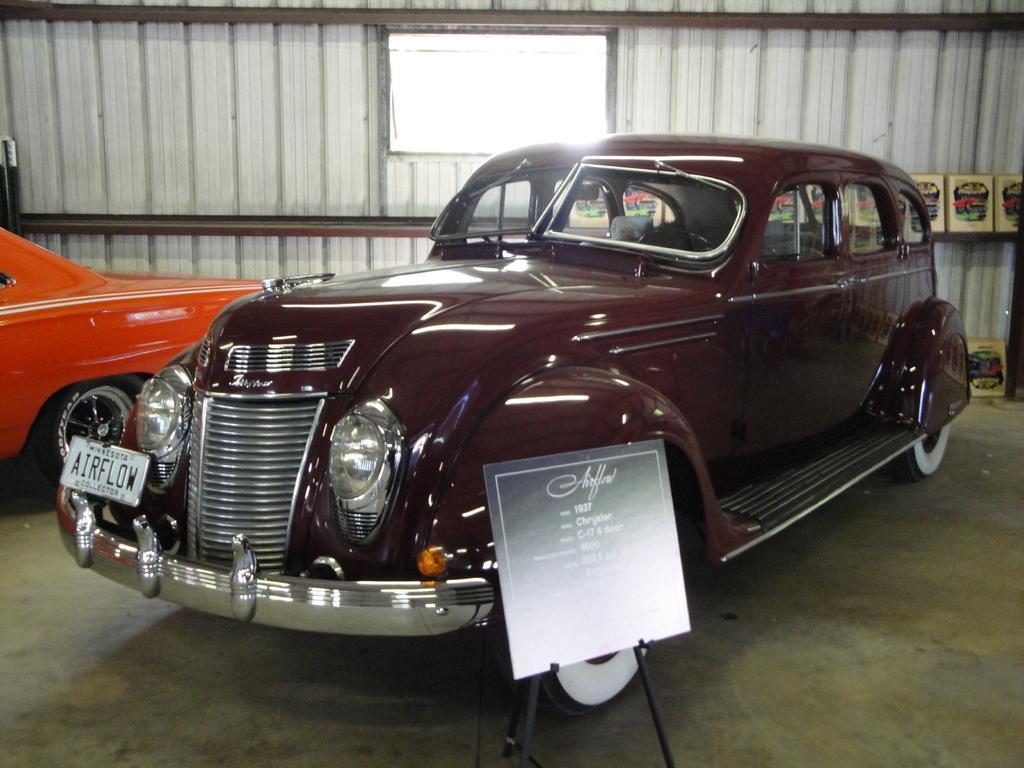Describe this image in one or two sentences. In this image I can see the vehicles inside the shed. These vehicles are in orange and dark brown color. And I can see the board in-front of the vehicle. In the back I can see the wooden wall and the window. 